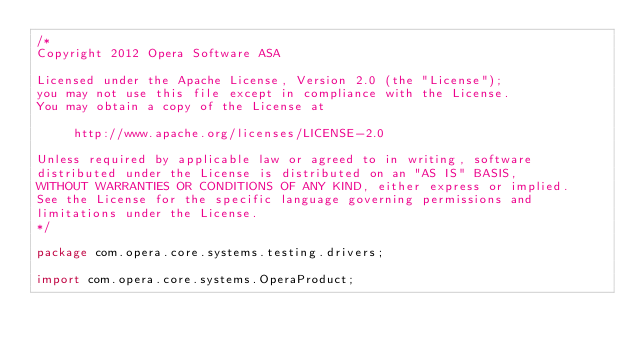<code> <loc_0><loc_0><loc_500><loc_500><_Java_>/*
Copyright 2012 Opera Software ASA

Licensed under the Apache License, Version 2.0 (the "License");
you may not use this file except in compliance with the License.
You may obtain a copy of the License at

     http://www.apache.org/licenses/LICENSE-2.0

Unless required by applicable law or agreed to in writing, software
distributed under the License is distributed on an "AS IS" BASIS,
WITHOUT WARRANTIES OR CONDITIONS OF ANY KIND, either express or implied.
See the License for the specific language governing permissions and
limitations under the License.
*/

package com.opera.core.systems.testing.drivers;

import com.opera.core.systems.OperaProduct;</code> 